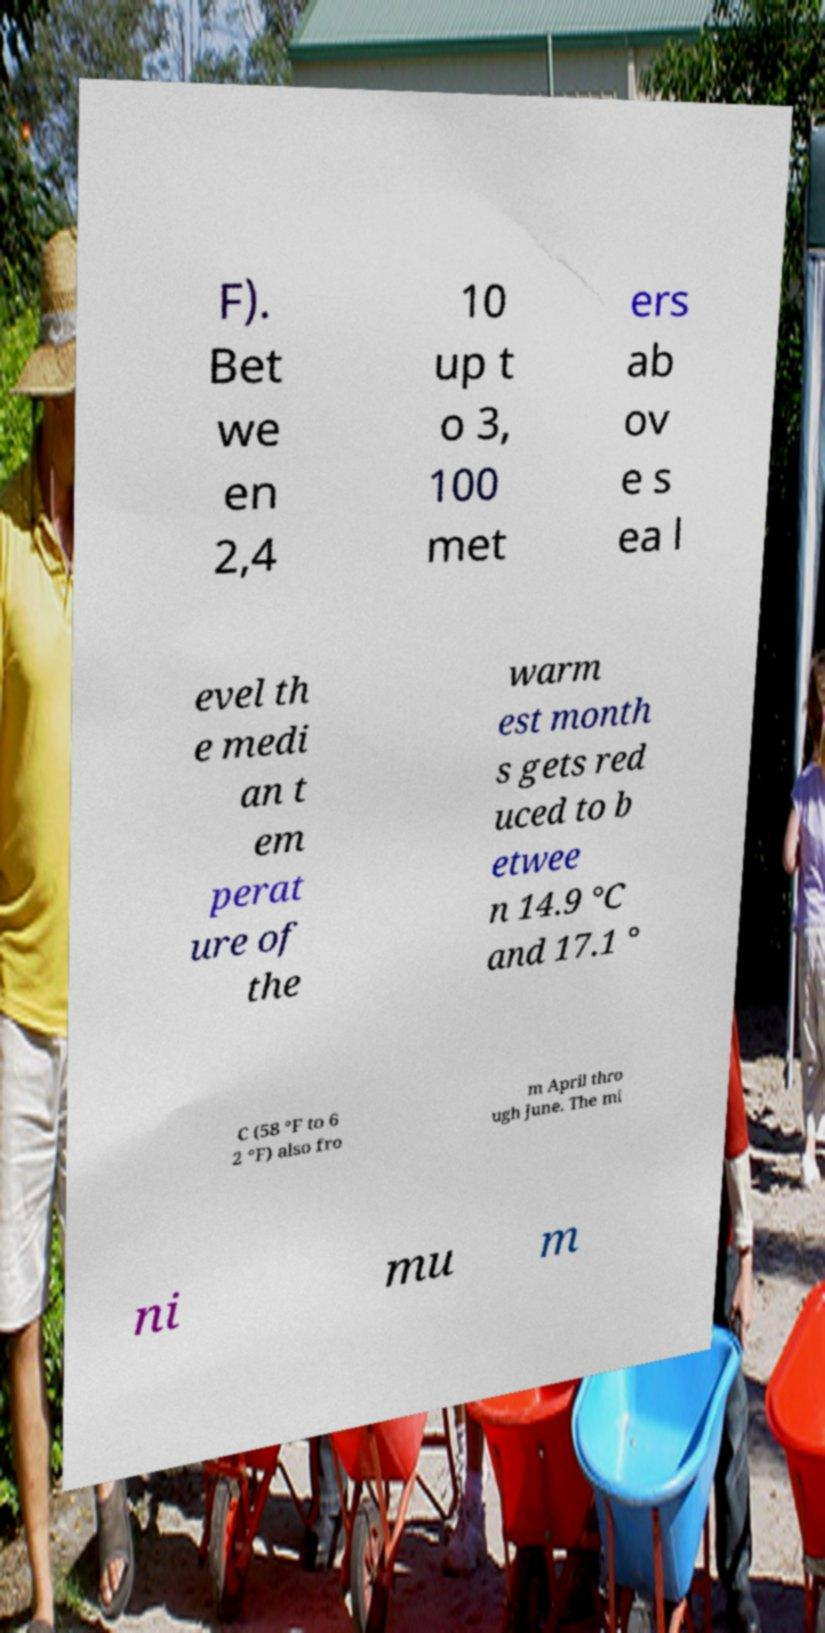There's text embedded in this image that I need extracted. Can you transcribe it verbatim? F). Bet we en 2,4 10 up t o 3, 100 met ers ab ov e s ea l evel th e medi an t em perat ure of the warm est month s gets red uced to b etwee n 14.9 °C and 17.1 ° C (58 °F to 6 2 °F) also fro m April thro ugh June. The mi ni mu m 